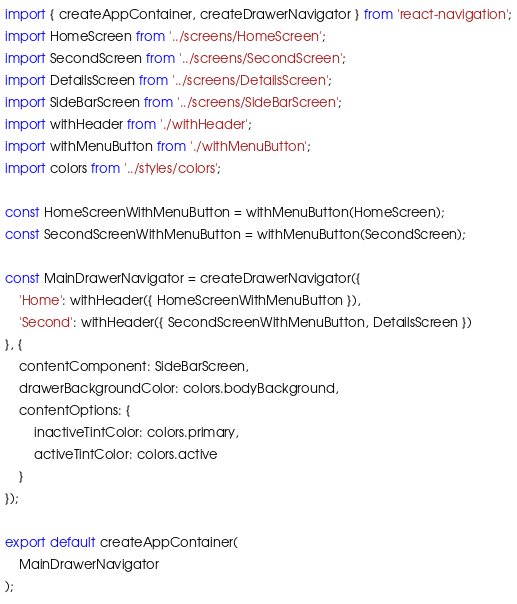<code> <loc_0><loc_0><loc_500><loc_500><_JavaScript_>import { createAppContainer, createDrawerNavigator } from 'react-navigation';
import HomeScreen from '../screens/HomeScreen';
import SecondScreen from '../screens/SecondScreen';
import DetailsScreen from '../screens/DetailsScreen';
import SideBarScreen from '../screens/SideBarScreen';
import withHeader from './withHeader';
import withMenuButton from './withMenuButton';
import colors from '../styles/colors';

const HomeScreenWithMenuButton = withMenuButton(HomeScreen);
const SecondScreenWithMenuButton = withMenuButton(SecondScreen);

const MainDrawerNavigator = createDrawerNavigator({
    'Home': withHeader({ HomeScreenWithMenuButton }),
    'Second': withHeader({ SecondScreenWithMenuButton, DetailsScreen })
}, {
    contentComponent: SideBarScreen,
    drawerBackgroundColor: colors.bodyBackground,
    contentOptions: {
        inactiveTintColor: colors.primary,
        activeTintColor: colors.active
    }
});

export default createAppContainer(
    MainDrawerNavigator
);
</code> 